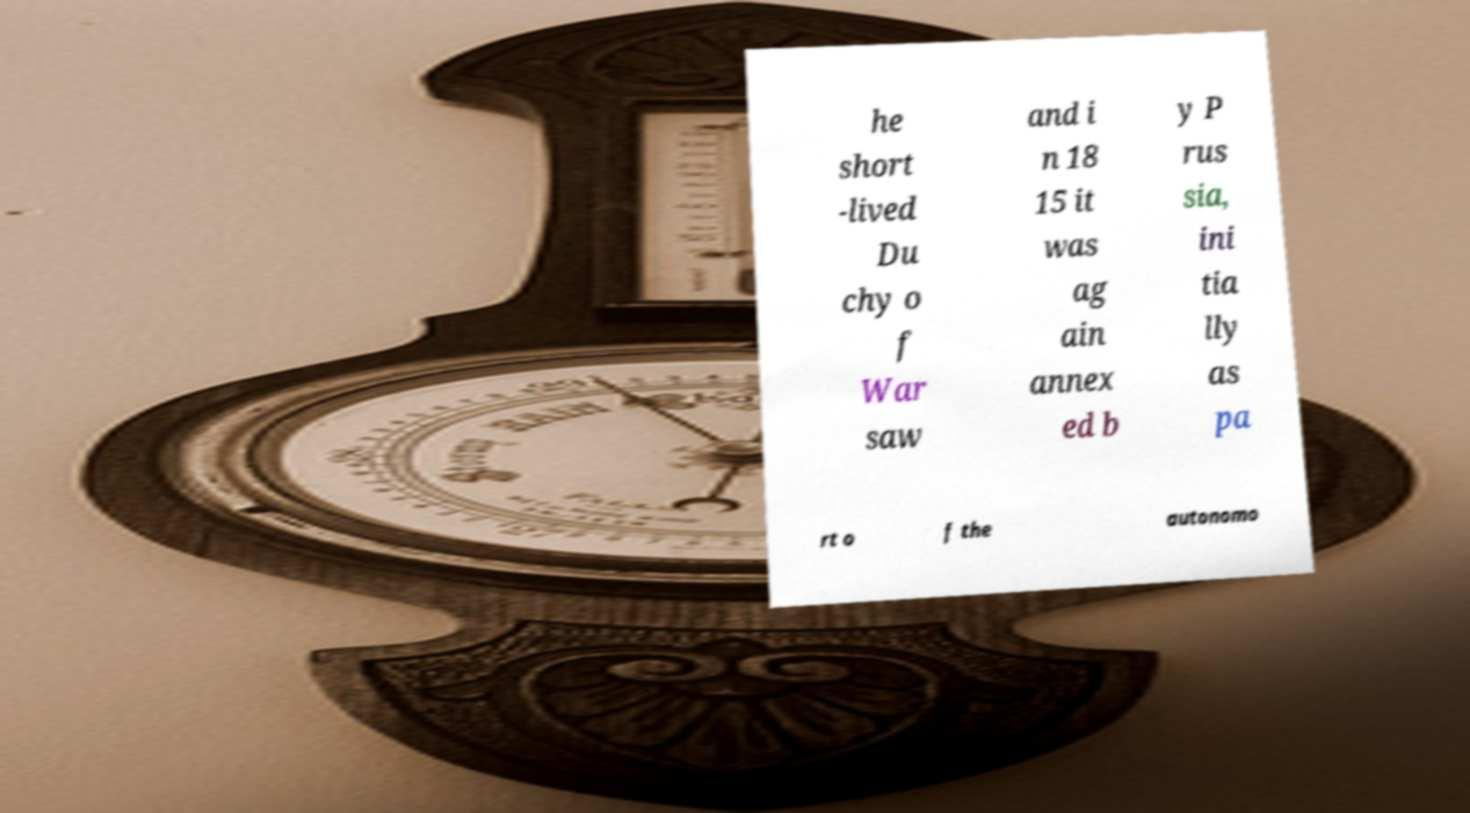For documentation purposes, I need the text within this image transcribed. Could you provide that? he short -lived Du chy o f War saw and i n 18 15 it was ag ain annex ed b y P rus sia, ini tia lly as pa rt o f the autonomo 